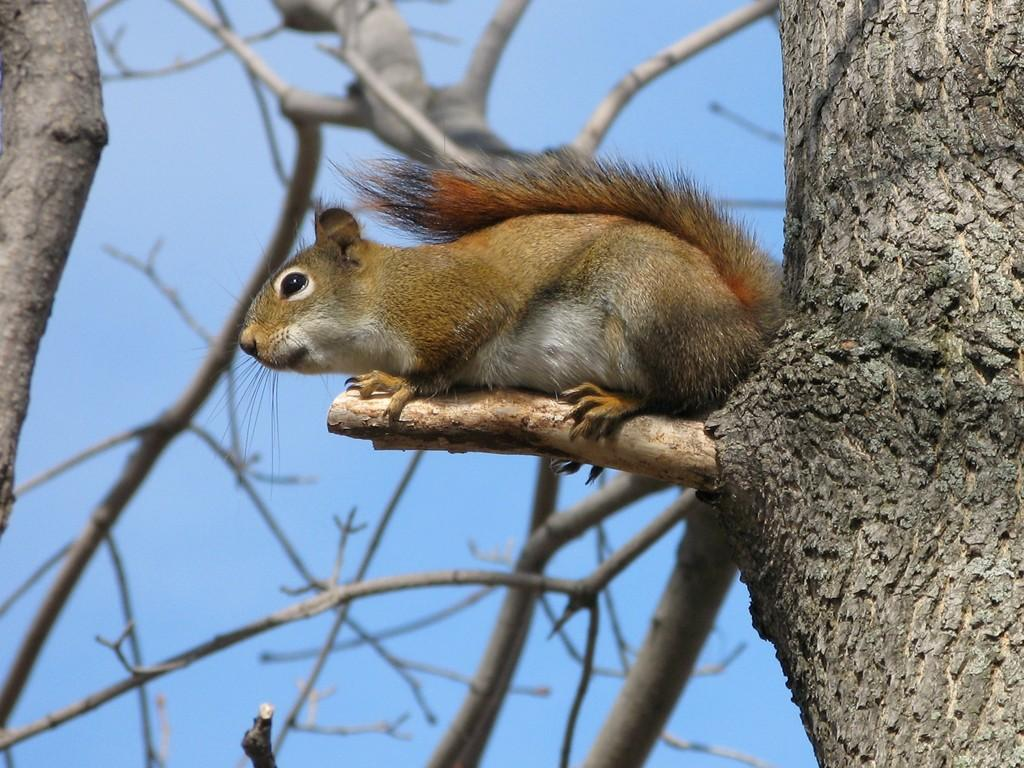What type of animal is in the image? There is a squirrel in the image. What is the squirrel doing in the image? The squirrel is sitting on a tree. What can be seen in the background of the image? The sky is visible in the background of the image. What type of flag is the squirrel holding in its body in the image? There is no flag present in the image, and the squirrel is not holding anything with its body. How many snakes are visible in the image? There are no snakes present in the image; it features a squirrel sitting on a tree. 